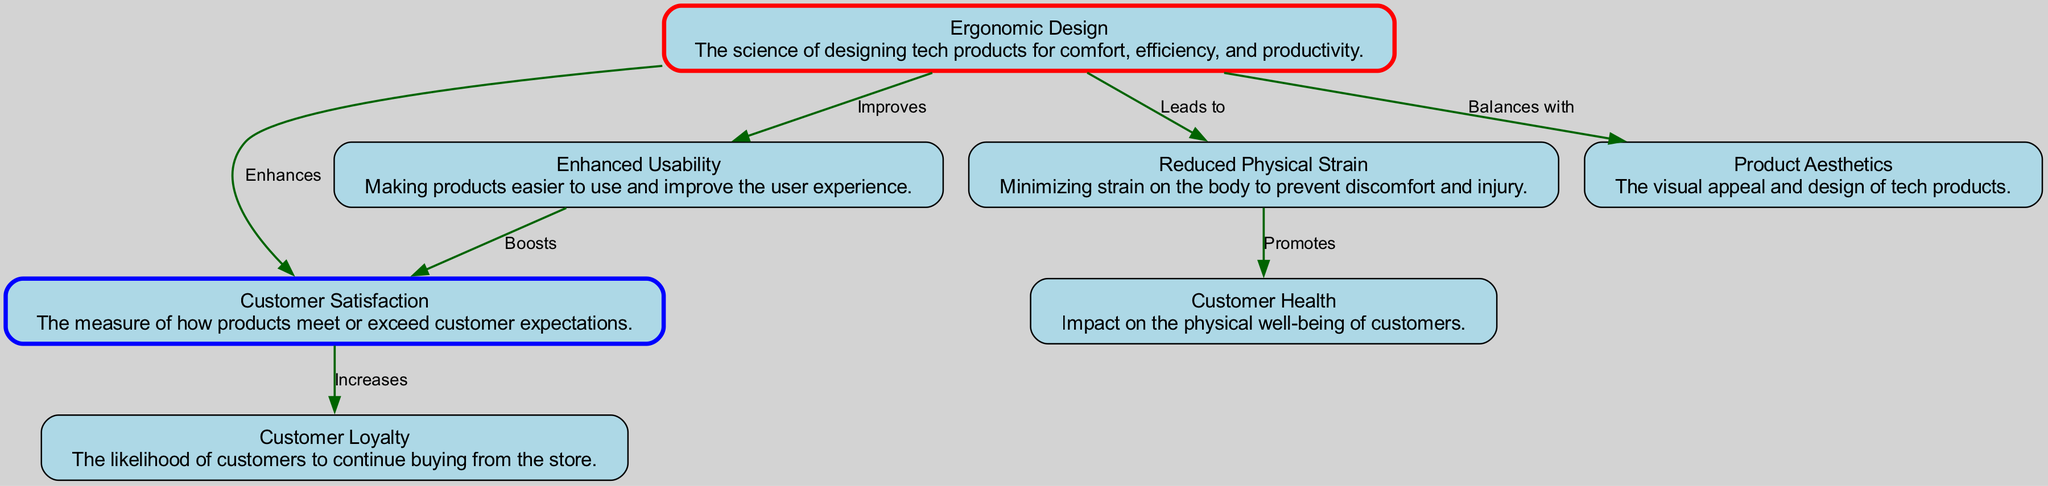What is the main focus of the diagram? The diagram centers on the impact of ergonomic design on customer satisfaction in tech products, highlighting the benefits and practices of ergonomic design.
Answer: Ergonomic Design How many nodes are present in the diagram? There are a total of seven distinct nodes listed in the diagram.
Answer: 7 What does ergonomic design enhance? According to the diagram, ergonomic design enhances customer satisfaction as indicated by the directed edge between the corresponding nodes.
Answer: Customer Satisfaction What is one benefit of ergonomic design as illustrated? Ergonomic design leads to reduced physical strain, which is clearly stated in the diagram.
Answer: Reduced Physical Strain Which two concepts are connected by the label "Increases" in the diagram? The label "Increases" is connecting customer satisfaction and customer loyalty.
Answer: Customer Satisfaction and Customer Loyalty What is the relationship between reduced physical strain and customer health? The diagram indicates that reduced physical strain promotes customer health, establishing a direct link between the two concepts.
Answer: Promotes How do enhanced usability and customer satisfaction relate? Enhanced usability boosts customer satisfaction, which can be seen by following the directed edge from enhanced usability to customer satisfaction in the diagram.
Answer: Boosts Which node represents the visual appeal of tech products? The node that represents the visual appeal of tech products is labeled product aesthetics.
Answer: Product Aesthetics What is balanced with ergonomic design according to the diagram? The diagram states that ergonomic design is balanced with product aesthetics, indicating a relationship between comfort and visual appeal.
Answer: Product Aesthetics 